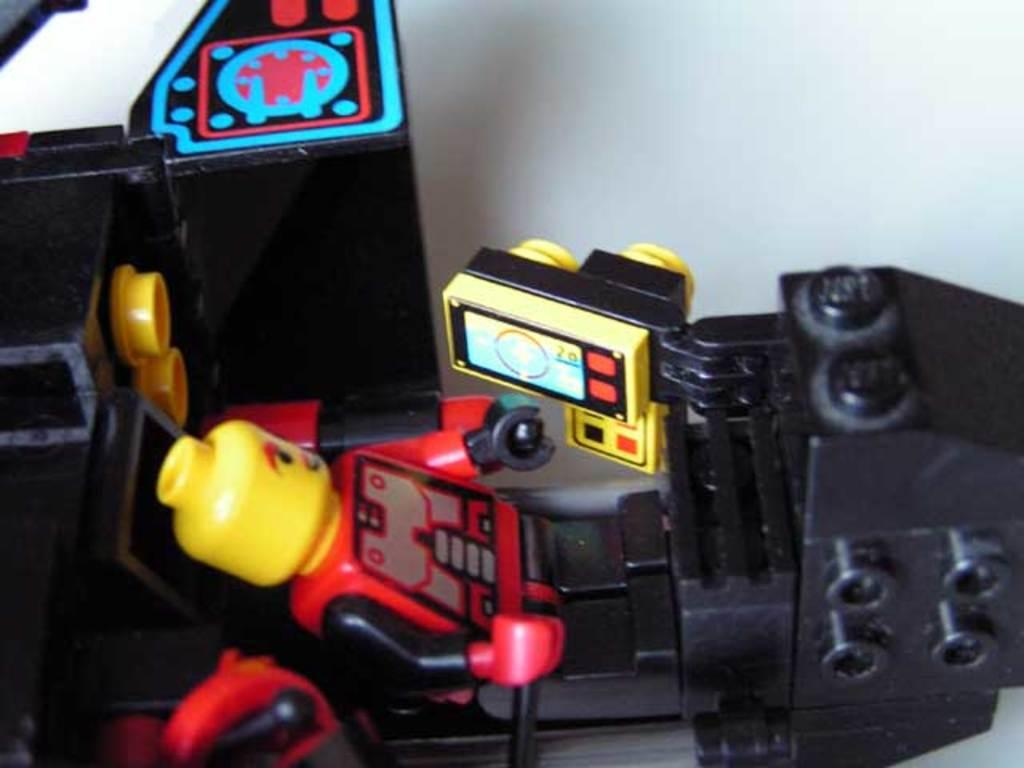What type of toy is depicted in the image? There is a toy motor vehicle made of Legos in the image. Can you describe the material used to create the toy? The toy motor vehicle is made of Legos. What is the primary function of the toy? The toy is a motor vehicle, which suggests it is meant for play and simulating driving or transportation. Is the toy motor vehicle stuck in quicksand in the image? No, there is no quicksand present in the image, and the toy motor vehicle is made of Legos, which are not capable of sinking into quicksand. 